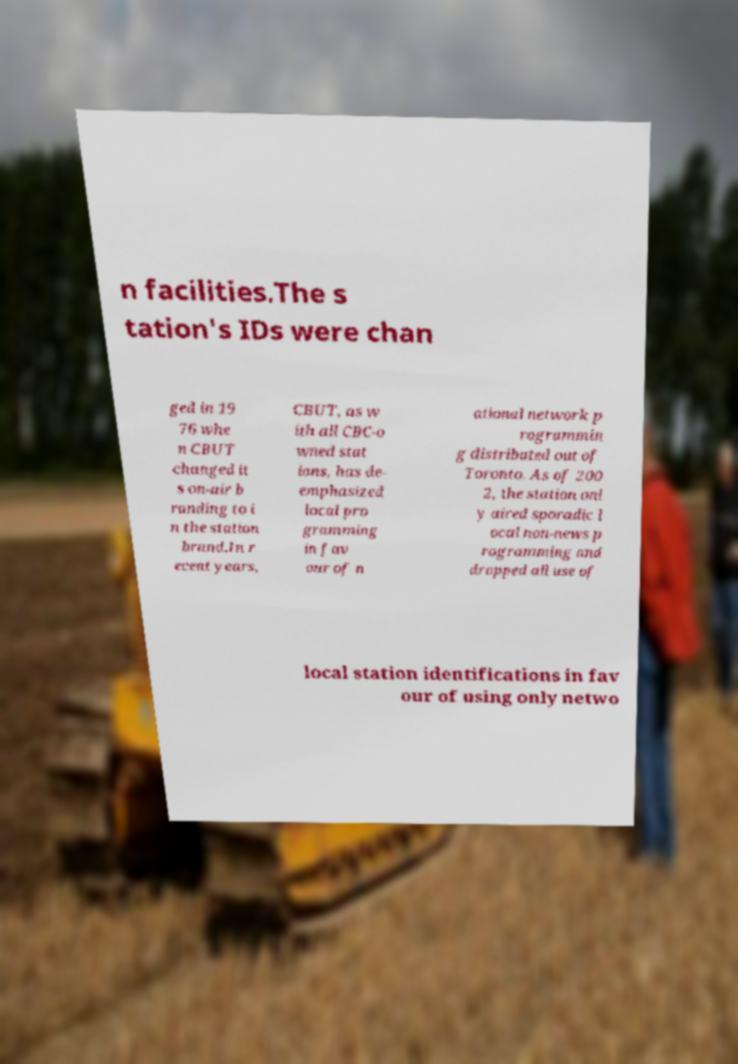What messages or text are displayed in this image? I need them in a readable, typed format. n facilities.The s tation's IDs were chan ged in 19 76 whe n CBUT changed it s on-air b randing to i n the station brand.In r ecent years, CBUT, as w ith all CBC-o wned stat ions, has de- emphasized local pro gramming in fav our of n ational network p rogrammin g distributed out of Toronto. As of 200 2, the station onl y aired sporadic l ocal non-news p rogramming and dropped all use of local station identifications in fav our of using only netwo 